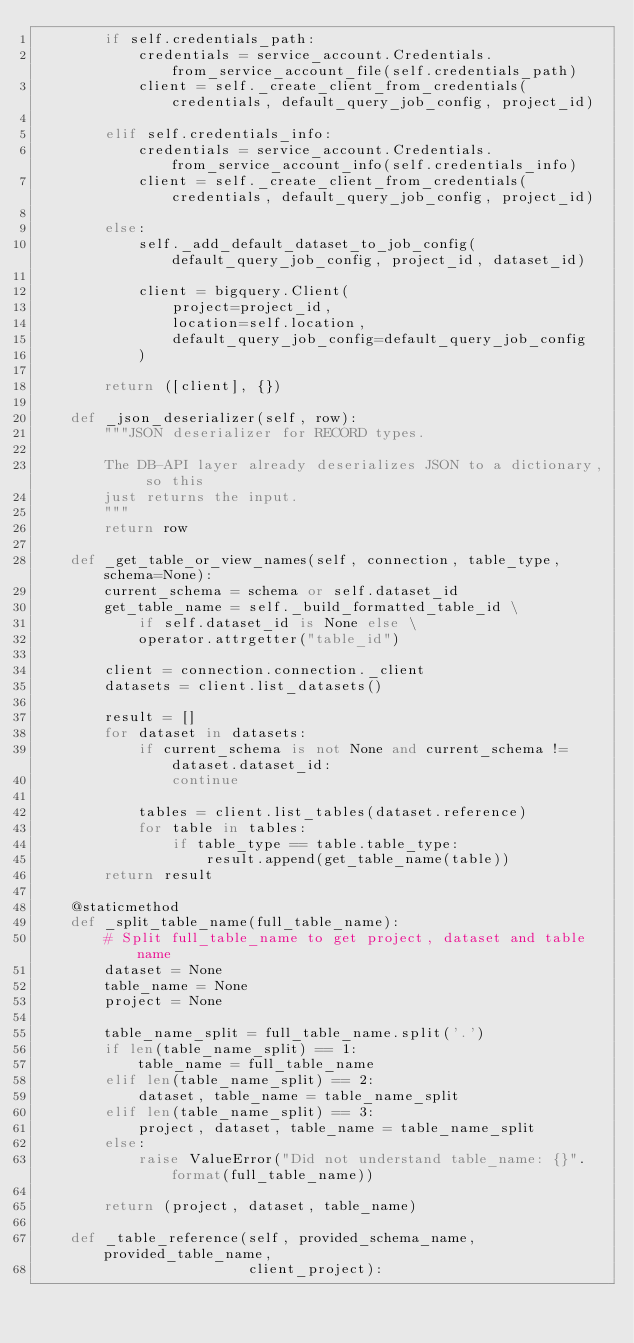<code> <loc_0><loc_0><loc_500><loc_500><_Python_>        if self.credentials_path:
            credentials = service_account.Credentials.from_service_account_file(self.credentials_path)
            client = self._create_client_from_credentials(credentials, default_query_job_config, project_id)

        elif self.credentials_info:
            credentials = service_account.Credentials.from_service_account_info(self.credentials_info)
            client = self._create_client_from_credentials(credentials, default_query_job_config, project_id)

        else:
            self._add_default_dataset_to_job_config(default_query_job_config, project_id, dataset_id)

            client = bigquery.Client(
                project=project_id,
                location=self.location,
                default_query_job_config=default_query_job_config
            )

        return ([client], {})

    def _json_deserializer(self, row):
        """JSON deserializer for RECORD types.

        The DB-API layer already deserializes JSON to a dictionary, so this
        just returns the input.
        """
        return row

    def _get_table_or_view_names(self, connection, table_type, schema=None):
        current_schema = schema or self.dataset_id
        get_table_name = self._build_formatted_table_id \
            if self.dataset_id is None else \
            operator.attrgetter("table_id")

        client = connection.connection._client
        datasets = client.list_datasets()

        result = []
        for dataset in datasets:
            if current_schema is not None and current_schema != dataset.dataset_id:
                continue

            tables = client.list_tables(dataset.reference)
            for table in tables:
                if table_type == table.table_type:
                    result.append(get_table_name(table))
        return result

    @staticmethod
    def _split_table_name(full_table_name):
        # Split full_table_name to get project, dataset and table name
        dataset = None
        table_name = None
        project = None

        table_name_split = full_table_name.split('.')
        if len(table_name_split) == 1:
            table_name = full_table_name
        elif len(table_name_split) == 2:
            dataset, table_name = table_name_split
        elif len(table_name_split) == 3:
            project, dataset, table_name = table_name_split
        else:
            raise ValueError("Did not understand table_name: {}".format(full_table_name))

        return (project, dataset, table_name)

    def _table_reference(self, provided_schema_name, provided_table_name,
                         client_project):</code> 